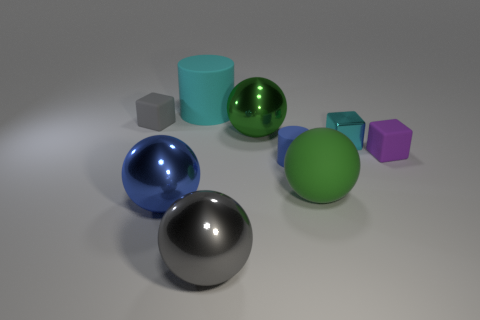Add 1 big balls. How many objects exist? 10 Subtract all spheres. How many objects are left? 5 Subtract all gray matte things. Subtract all rubber cylinders. How many objects are left? 6 Add 7 small purple matte cubes. How many small purple matte cubes are left? 8 Add 5 cylinders. How many cylinders exist? 7 Subtract 1 cyan blocks. How many objects are left? 8 